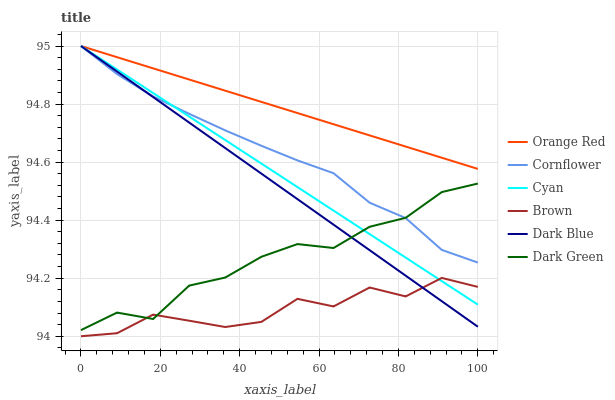Does Dark Blue have the minimum area under the curve?
Answer yes or no. No. Does Dark Blue have the maximum area under the curve?
Answer yes or no. No. Is Dark Blue the smoothest?
Answer yes or no. No. Is Dark Blue the roughest?
Answer yes or no. No. Does Dark Blue have the lowest value?
Answer yes or no. No. Does Brown have the highest value?
Answer yes or no. No. Is Brown less than Orange Red?
Answer yes or no. Yes. Is Orange Red greater than Brown?
Answer yes or no. Yes. Does Brown intersect Orange Red?
Answer yes or no. No. 